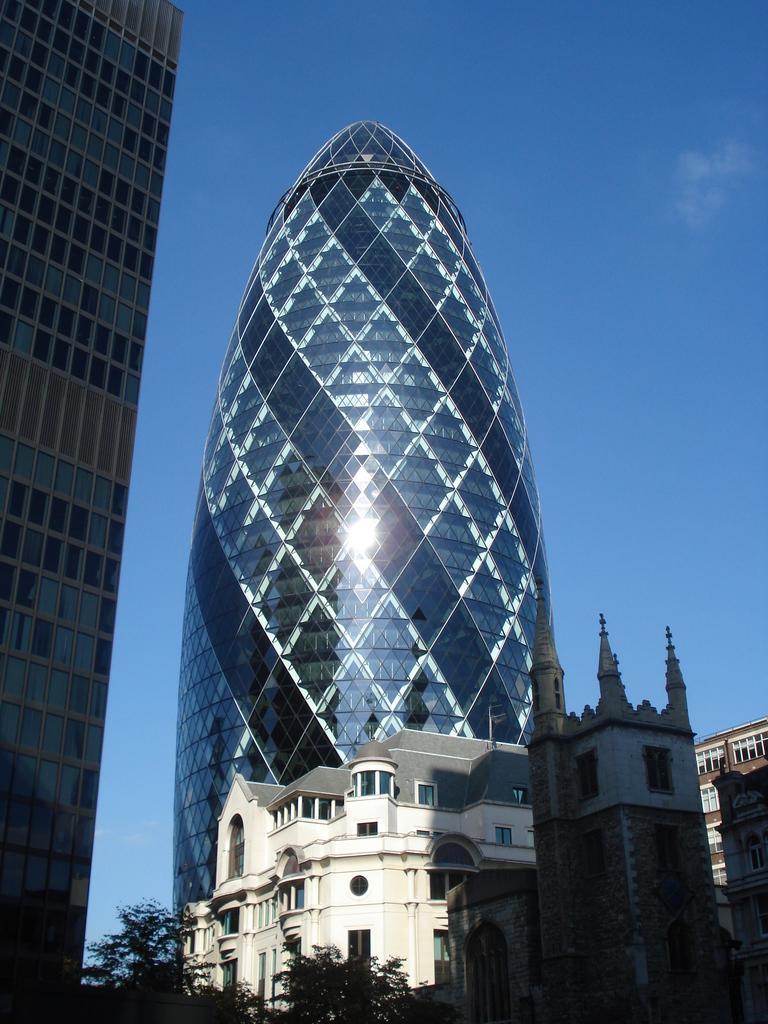Can you describe this image briefly? In this image, we can see buildings and trees and at the top, there is sky. 